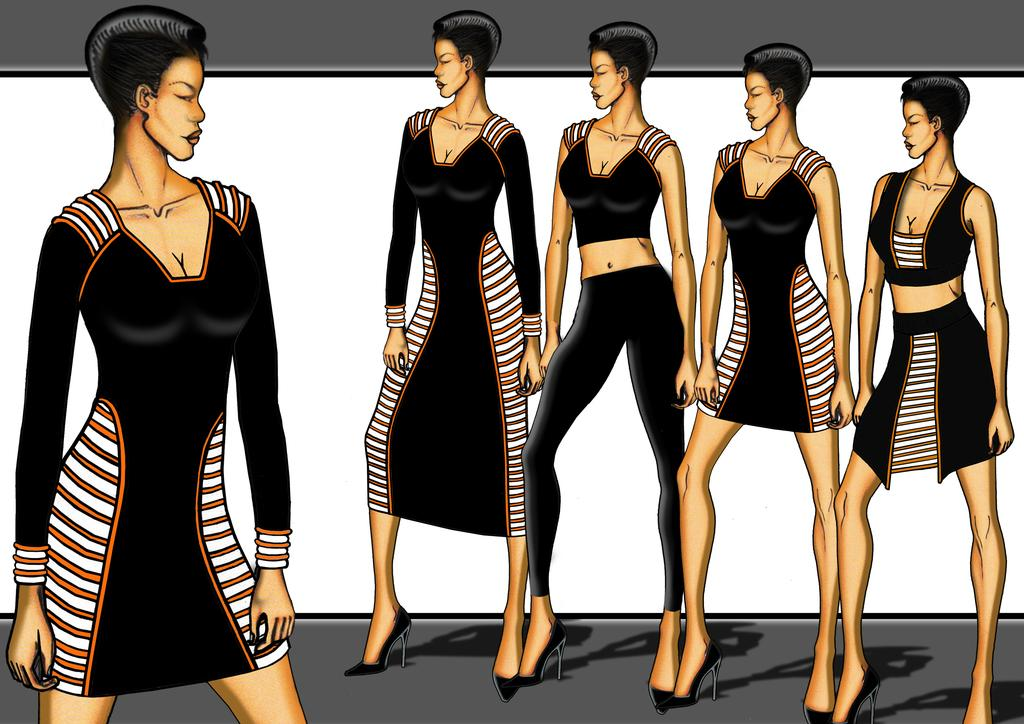What type of image is being described? The image is animated. Who or what can be seen in the image? There are ladies in the image. What are the ladies wearing? The ladies are wearing different types of dresses. What is the color of the background in the image? The background in the image is white. What type of shoes are the girls wearing in the image? There are no girls mentioned in the facts provided, only ladies. Additionally, the image is animated, so it's not possible to determine the type of shoes they might be wearing. 